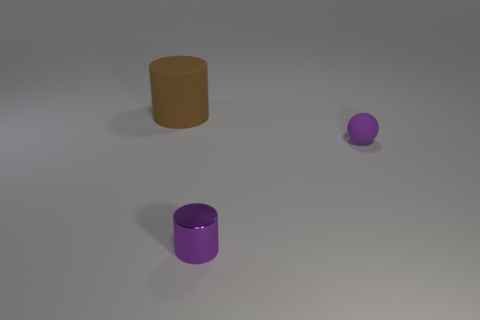Add 3 tiny metallic objects. How many objects exist? 6 Subtract all matte cylinders. Subtract all small green shiny blocks. How many objects are left? 2 Add 1 tiny purple spheres. How many tiny purple spheres are left? 2 Add 1 big green things. How many big green things exist? 1 Subtract 0 gray spheres. How many objects are left? 3 Subtract all cylinders. How many objects are left? 1 Subtract all brown balls. Subtract all blue cylinders. How many balls are left? 1 